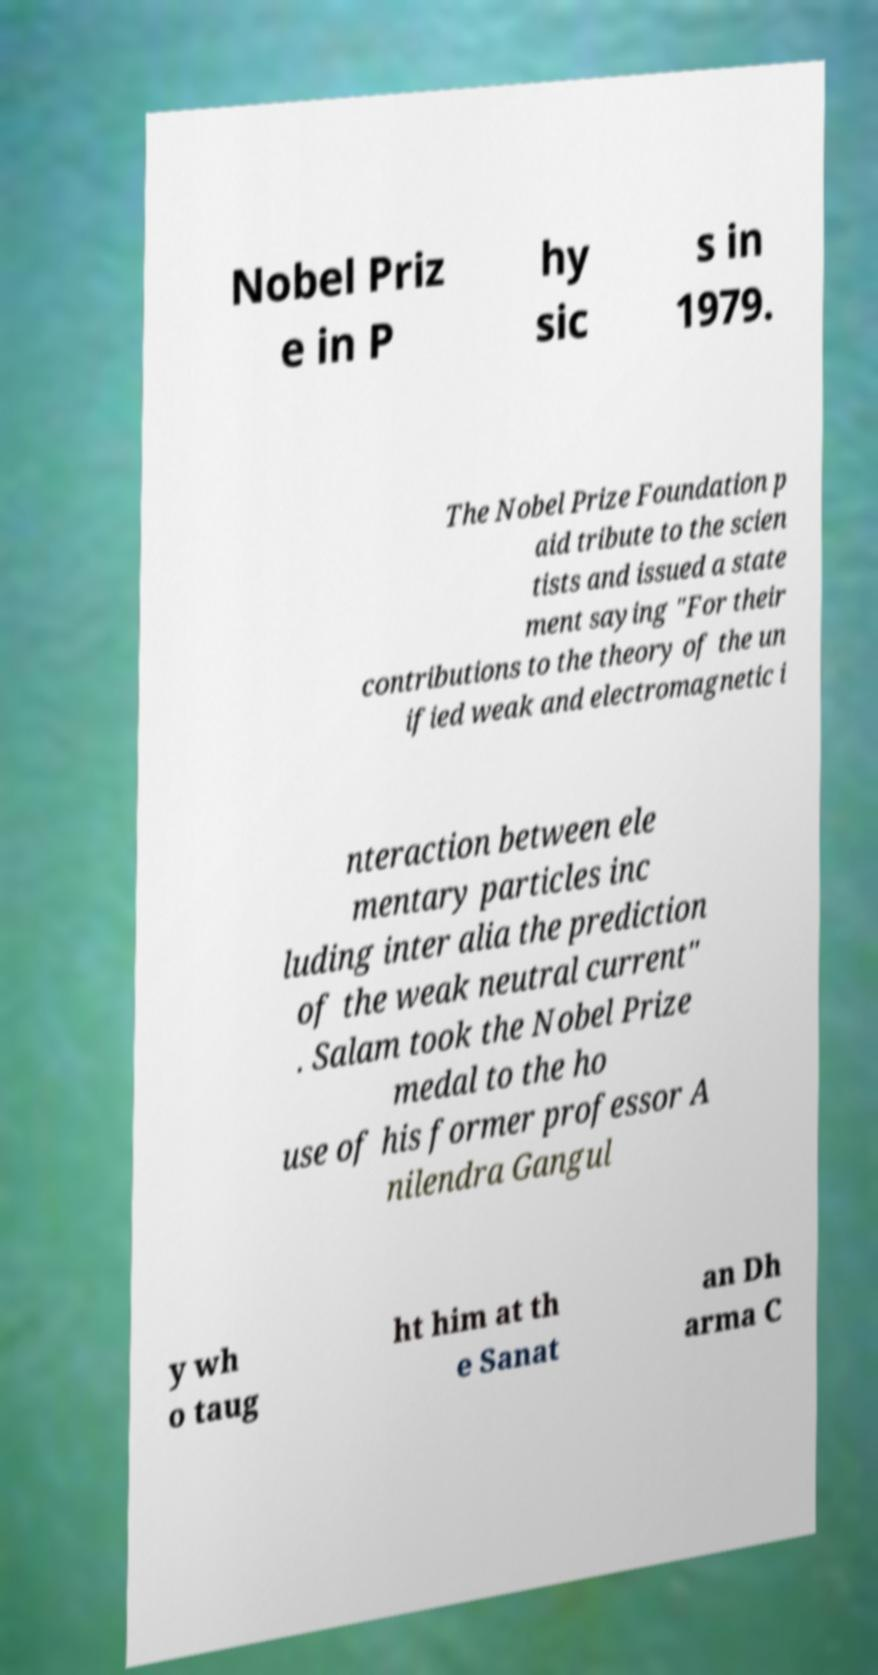Can you read and provide the text displayed in the image?This photo seems to have some interesting text. Can you extract and type it out for me? Nobel Priz e in P hy sic s in 1979. The Nobel Prize Foundation p aid tribute to the scien tists and issued a state ment saying "For their contributions to the theory of the un ified weak and electromagnetic i nteraction between ele mentary particles inc luding inter alia the prediction of the weak neutral current" . Salam took the Nobel Prize medal to the ho use of his former professor A nilendra Gangul y wh o taug ht him at th e Sanat an Dh arma C 